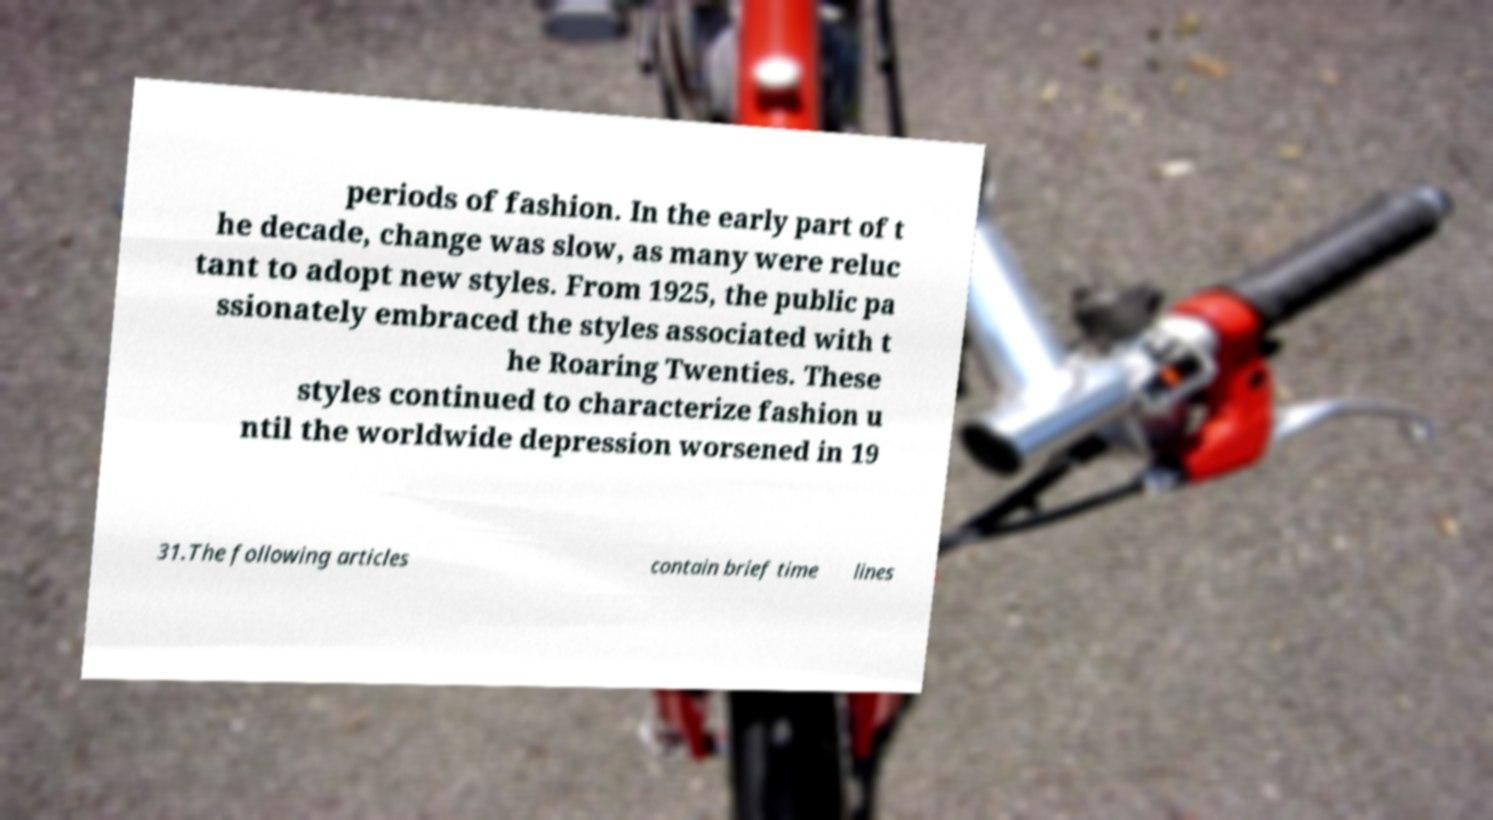Can you read and provide the text displayed in the image?This photo seems to have some interesting text. Can you extract and type it out for me? periods of fashion. In the early part of t he decade, change was slow, as many were reluc tant to adopt new styles. From 1925, the public pa ssionately embraced the styles associated with t he Roaring Twenties. These styles continued to characterize fashion u ntil the worldwide depression worsened in 19 31.The following articles contain brief time lines 